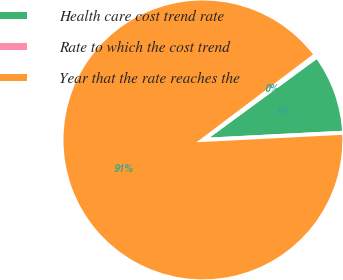Convert chart to OTSL. <chart><loc_0><loc_0><loc_500><loc_500><pie_chart><fcel>Health care cost trend rate<fcel>Rate to which the cost trend<fcel>Year that the rate reaches the<nl><fcel>9.25%<fcel>0.22%<fcel>90.52%<nl></chart> 